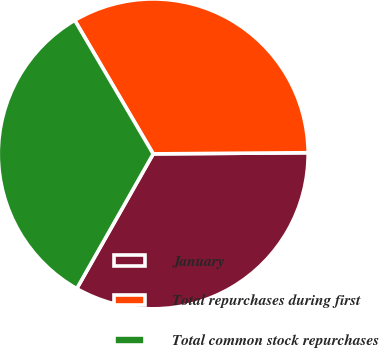Convert chart to OTSL. <chart><loc_0><loc_0><loc_500><loc_500><pie_chart><fcel>January<fcel>Total repurchases during first<fcel>Total common stock repurchases<nl><fcel>33.33%<fcel>33.33%<fcel>33.33%<nl></chart> 